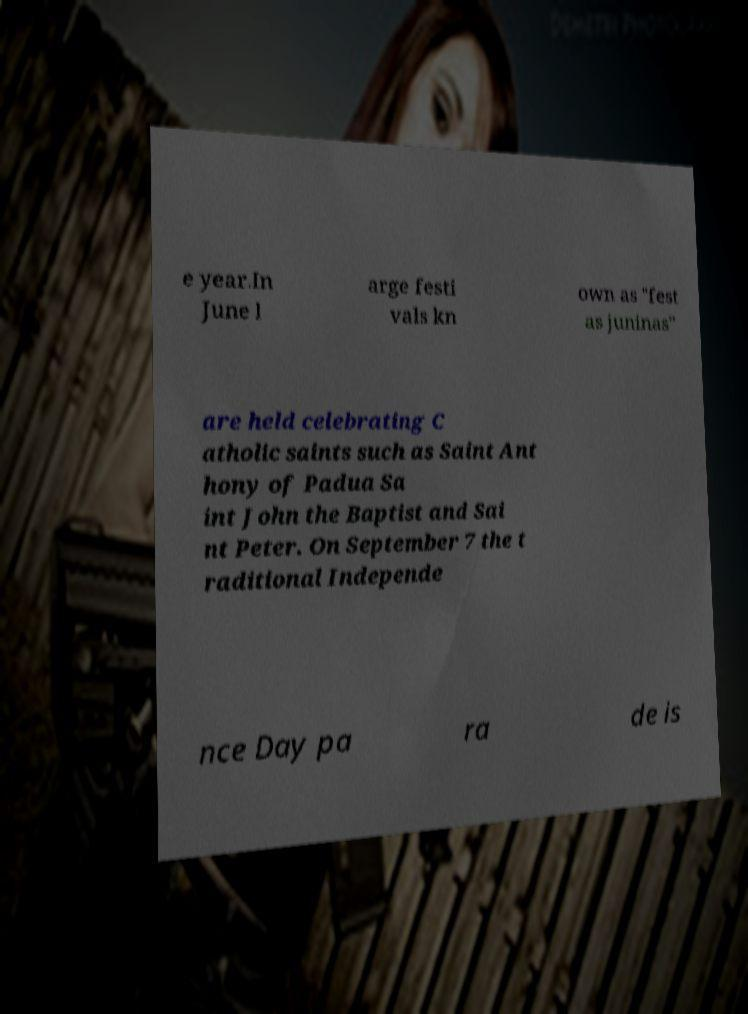For documentation purposes, I need the text within this image transcribed. Could you provide that? e year.In June l arge festi vals kn own as "fest as juninas" are held celebrating C atholic saints such as Saint Ant hony of Padua Sa int John the Baptist and Sai nt Peter. On September 7 the t raditional Independe nce Day pa ra de is 